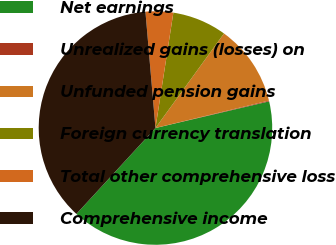Convert chart. <chart><loc_0><loc_0><loc_500><loc_500><pie_chart><fcel>Net earnings<fcel>Unrealized gains (losses) on<fcel>Unfunded pension gains<fcel>Foreign currency translation<fcel>Total other comprehensive loss<fcel>Comprehensive income<nl><fcel>40.5%<fcel>0.11%<fcel>11.24%<fcel>7.53%<fcel>3.82%<fcel>36.79%<nl></chart> 